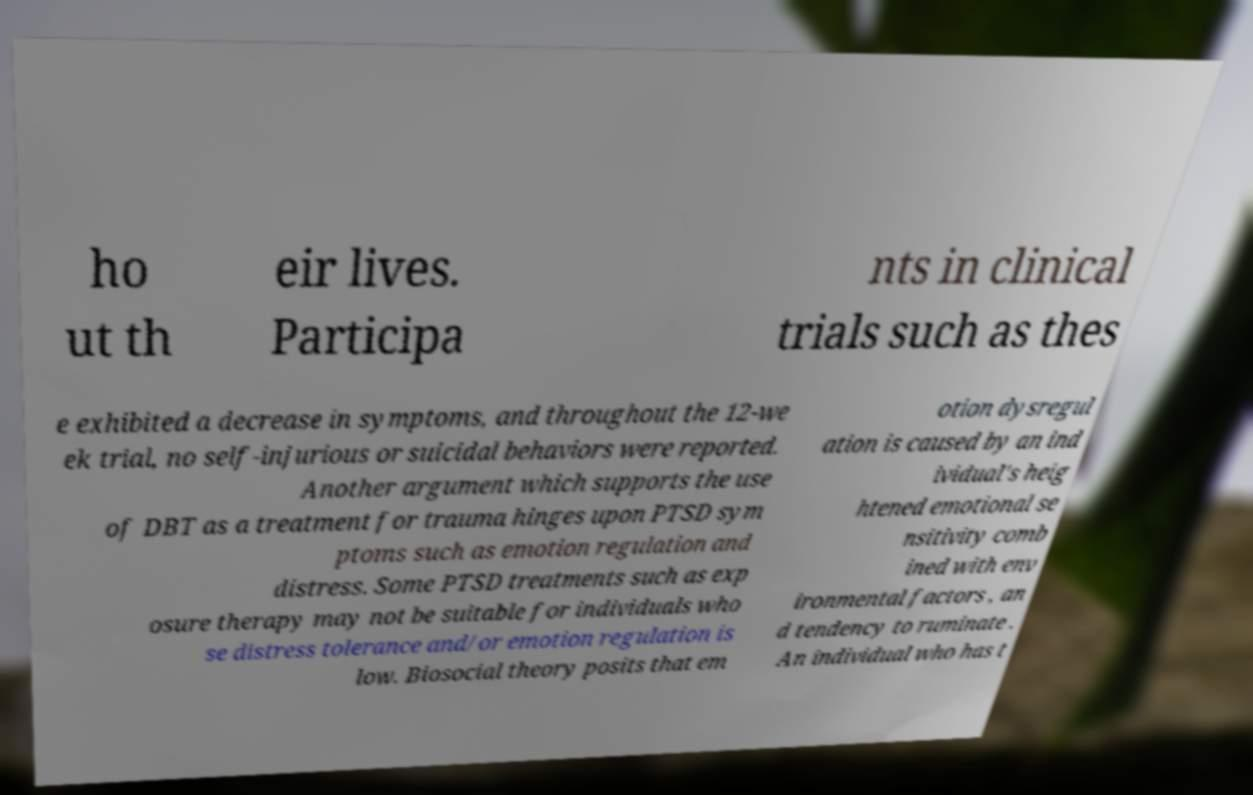Can you accurately transcribe the text from the provided image for me? ho ut th eir lives. Participa nts in clinical trials such as thes e exhibited a decrease in symptoms, and throughout the 12-we ek trial, no self-injurious or suicidal behaviors were reported. Another argument which supports the use of DBT as a treatment for trauma hinges upon PTSD sym ptoms such as emotion regulation and distress. Some PTSD treatments such as exp osure therapy may not be suitable for individuals who se distress tolerance and/or emotion regulation is low. Biosocial theory posits that em otion dysregul ation is caused by an ind ividual's heig htened emotional se nsitivity comb ined with env ironmental factors , an d tendency to ruminate . An individual who has t 